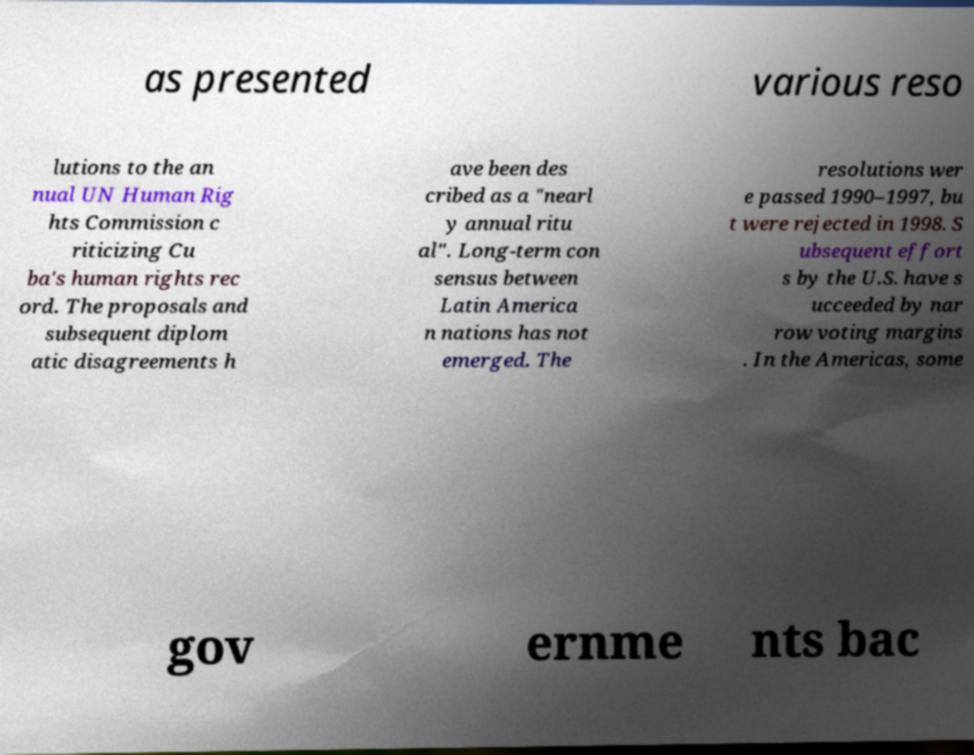Can you read and provide the text displayed in the image?This photo seems to have some interesting text. Can you extract and type it out for me? as presented various reso lutions to the an nual UN Human Rig hts Commission c riticizing Cu ba's human rights rec ord. The proposals and subsequent diplom atic disagreements h ave been des cribed as a "nearl y annual ritu al". Long-term con sensus between Latin America n nations has not emerged. The resolutions wer e passed 1990–1997, bu t were rejected in 1998. S ubsequent effort s by the U.S. have s ucceeded by nar row voting margins . In the Americas, some gov ernme nts bac 